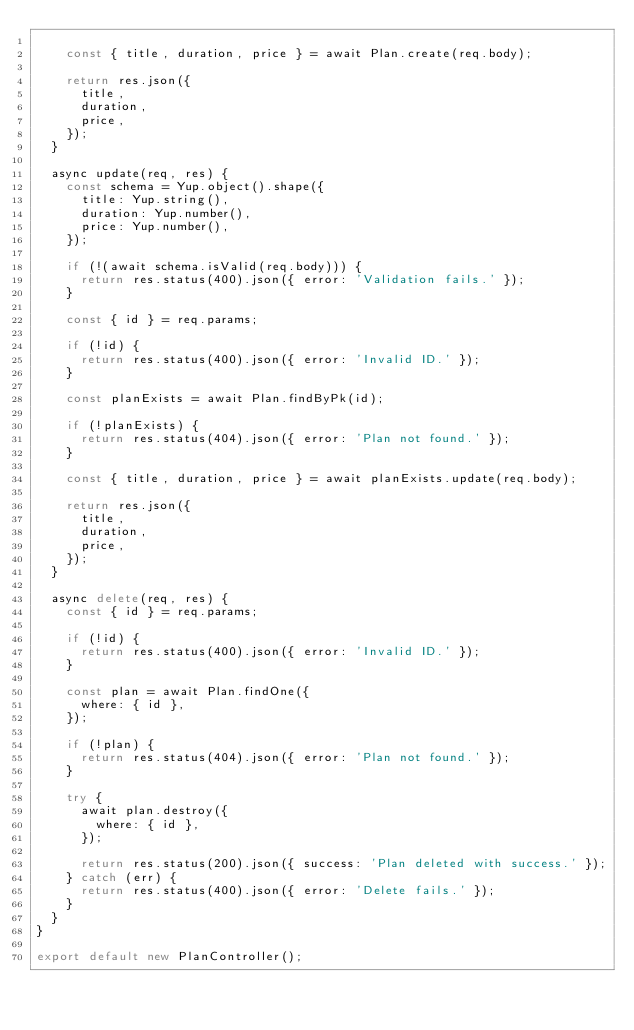Convert code to text. <code><loc_0><loc_0><loc_500><loc_500><_JavaScript_>
    const { title, duration, price } = await Plan.create(req.body);

    return res.json({
      title,
      duration,
      price,
    });
  }

  async update(req, res) {
    const schema = Yup.object().shape({
      title: Yup.string(),
      duration: Yup.number(),
      price: Yup.number(),
    });

    if (!(await schema.isValid(req.body))) {
      return res.status(400).json({ error: 'Validation fails.' });
    }

    const { id } = req.params;

    if (!id) {
      return res.status(400).json({ error: 'Invalid ID.' });
    }

    const planExists = await Plan.findByPk(id);

    if (!planExists) {
      return res.status(404).json({ error: 'Plan not found.' });
    }

    const { title, duration, price } = await planExists.update(req.body);

    return res.json({
      title,
      duration,
      price,
    });
  }

  async delete(req, res) {
    const { id } = req.params;

    if (!id) {
      return res.status(400).json({ error: 'Invalid ID.' });
    }

    const plan = await Plan.findOne({
      where: { id },
    });

    if (!plan) {
      return res.status(404).json({ error: 'Plan not found.' });
    }

    try {
      await plan.destroy({
        where: { id },
      });

      return res.status(200).json({ success: 'Plan deleted with success.' });
    } catch (err) {
      return res.status(400).json({ error: 'Delete fails.' });
    }
  }
}

export default new PlanController();
</code> 